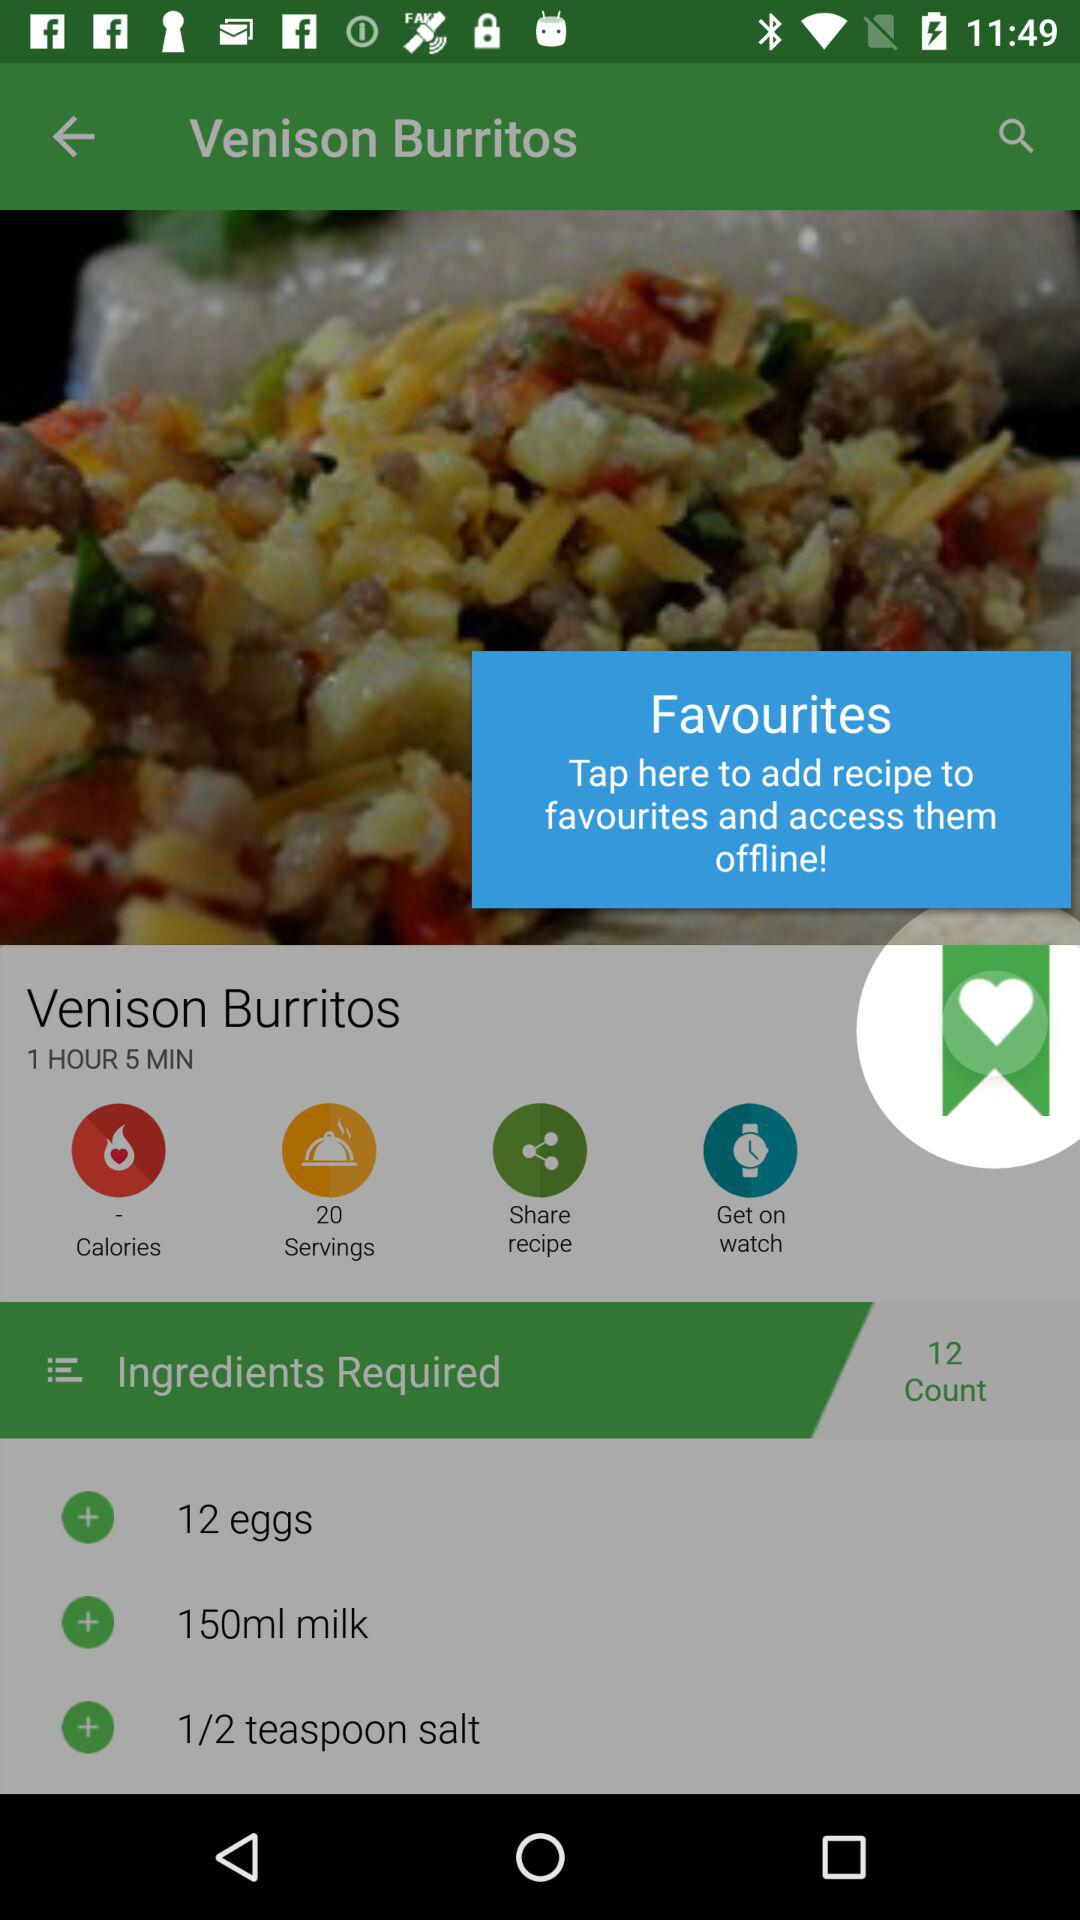What's the total number of servings? The total number of servings is 20. 